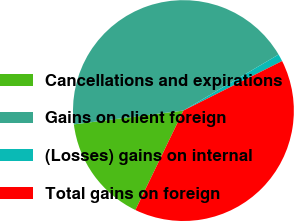<chart> <loc_0><loc_0><loc_500><loc_500><pie_chart><fcel>Cancellations and expirations<fcel>Gains on client foreign<fcel>(Losses) gains on internal<fcel>Total gains on foreign<nl><fcel>15.85%<fcel>43.52%<fcel>1.07%<fcel>39.56%<nl></chart> 